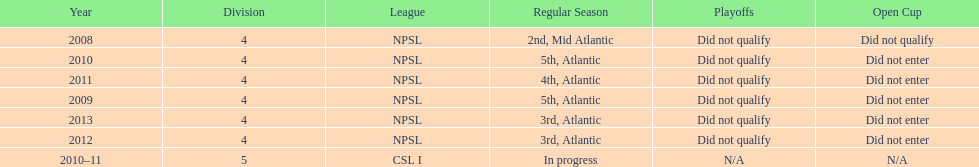Using the data, what should be the next year they will play? 2014. 